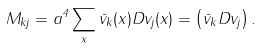<formula> <loc_0><loc_0><loc_500><loc_500>M _ { k j } = a ^ { 4 } \sum _ { x } \bar { v } _ { k } ( x ) D v _ { j } ( x ) = \left ( \bar { v } _ { k } D v _ { j } \right ) .</formula> 